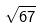<formula> <loc_0><loc_0><loc_500><loc_500>\sqrt { 6 7 }</formula> 